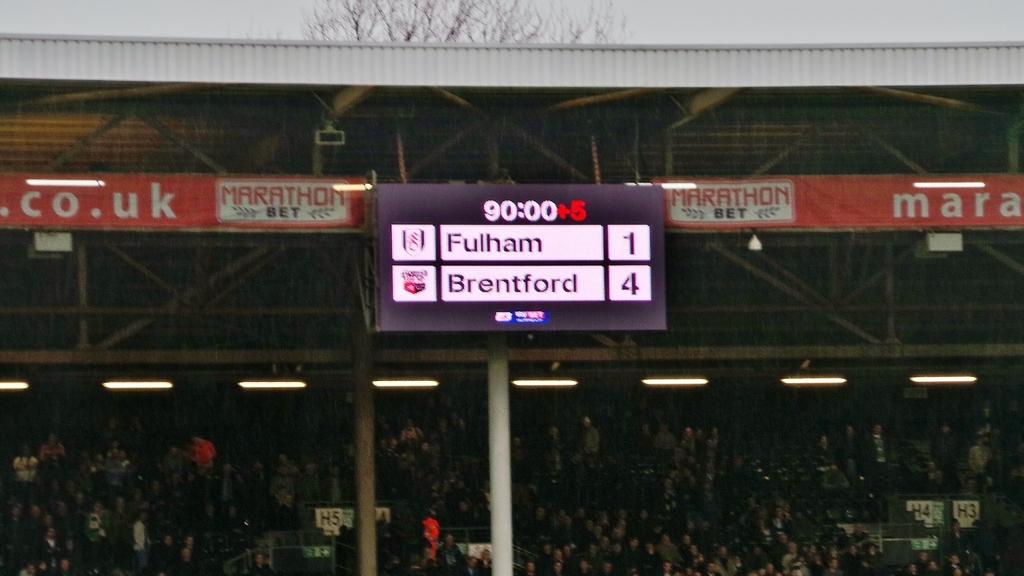Who is winning the game?
Your answer should be compact. Brentford. What kind of bet is shown on the banner?
Offer a terse response. Marathon. 